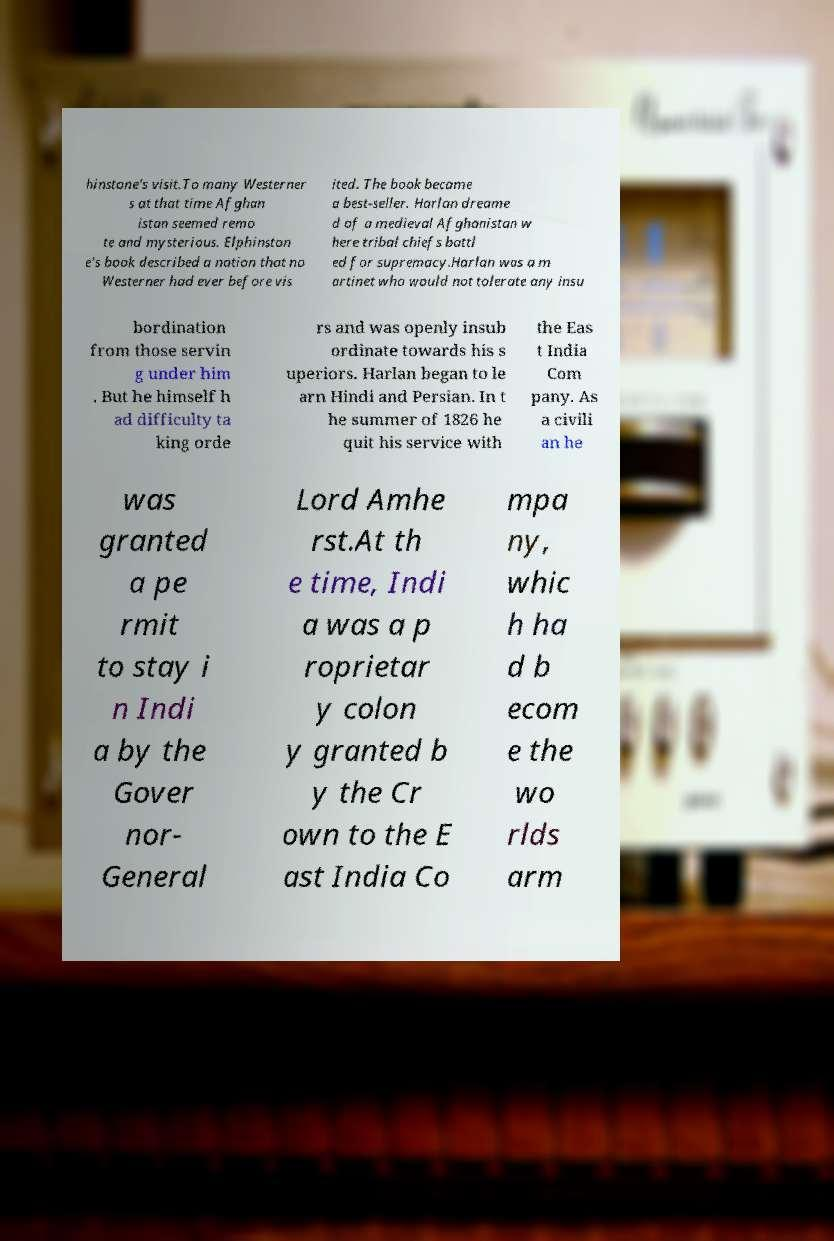For documentation purposes, I need the text within this image transcribed. Could you provide that? hinstone's visit.To many Westerner s at that time Afghan istan seemed remo te and mysterious. Elphinston e's book described a nation that no Westerner had ever before vis ited. The book became a best-seller. Harlan dreame d of a medieval Afghanistan w here tribal chiefs battl ed for supremacy.Harlan was a m artinet who would not tolerate any insu bordination from those servin g under him . But he himself h ad difficulty ta king orde rs and was openly insub ordinate towards his s uperiors. Harlan began to le arn Hindi and Persian. In t he summer of 1826 he quit his service with the Eas t India Com pany. As a civili an he was granted a pe rmit to stay i n Indi a by the Gover nor- General Lord Amhe rst.At th e time, Indi a was a p roprietar y colon y granted b y the Cr own to the E ast India Co mpa ny, whic h ha d b ecom e the wo rlds arm 